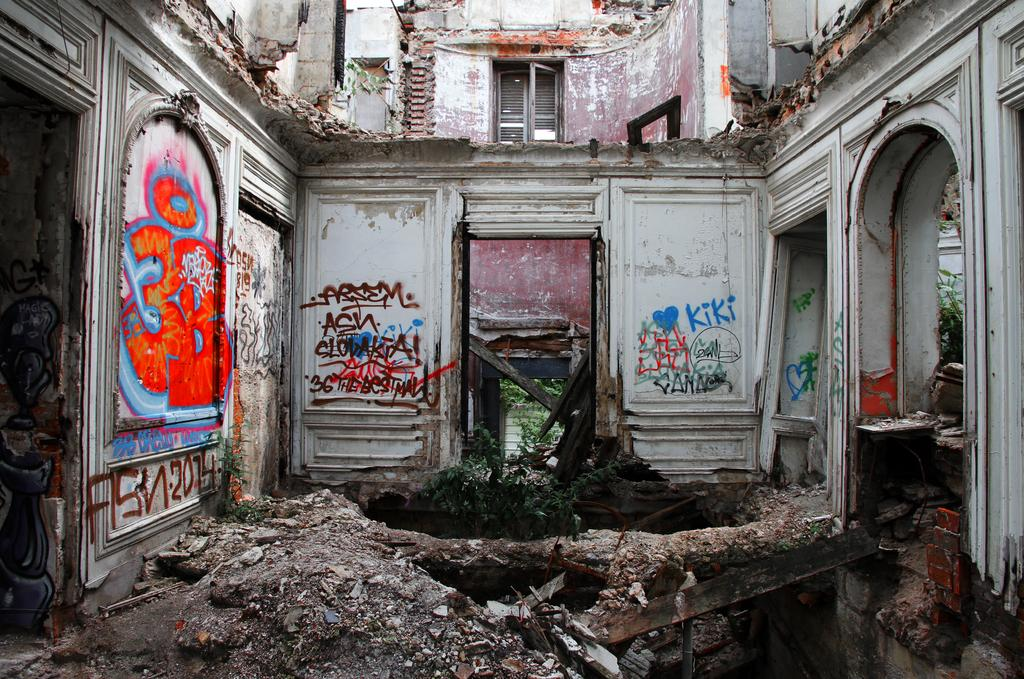What type of structures can be seen in the image? There are buildings in the image. Can you describe a specific feature of one of the buildings? There is a window visible in the image. What type of decoration is present on the wall of one of the buildings? There is a painting on a wall in the image. What type of wool is used to create the painting in the image? There is no wool mentioned or visible in the image; the painting is on a wall. 